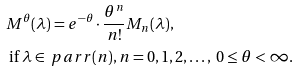Convert formula to latex. <formula><loc_0><loc_0><loc_500><loc_500>& M ^ { \theta } ( \lambda ) = e ^ { - \theta } \cdot \frac { \theta ^ { n } } { n ! } M _ { n } ( \lambda ) , \\ & \text { if } \lambda \in \ p a r r ( n ) , n = 0 , 1 , 2 , \dots , \ 0 \leq \theta < \infty .</formula> 